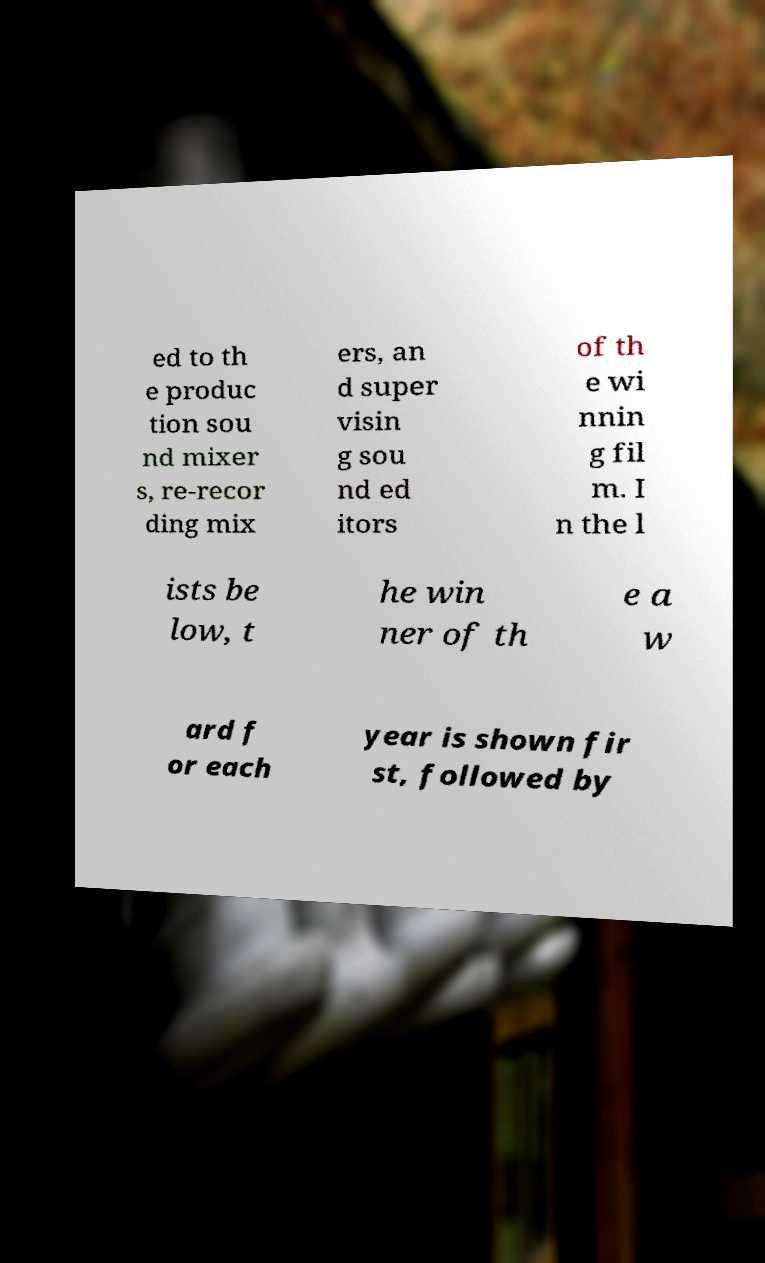For documentation purposes, I need the text within this image transcribed. Could you provide that? ed to th e produc tion sou nd mixer s, re-recor ding mix ers, an d super visin g sou nd ed itors of th e wi nnin g fil m. I n the l ists be low, t he win ner of th e a w ard f or each year is shown fir st, followed by 